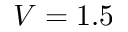<formula> <loc_0><loc_0><loc_500><loc_500>V = 1 . 5</formula> 